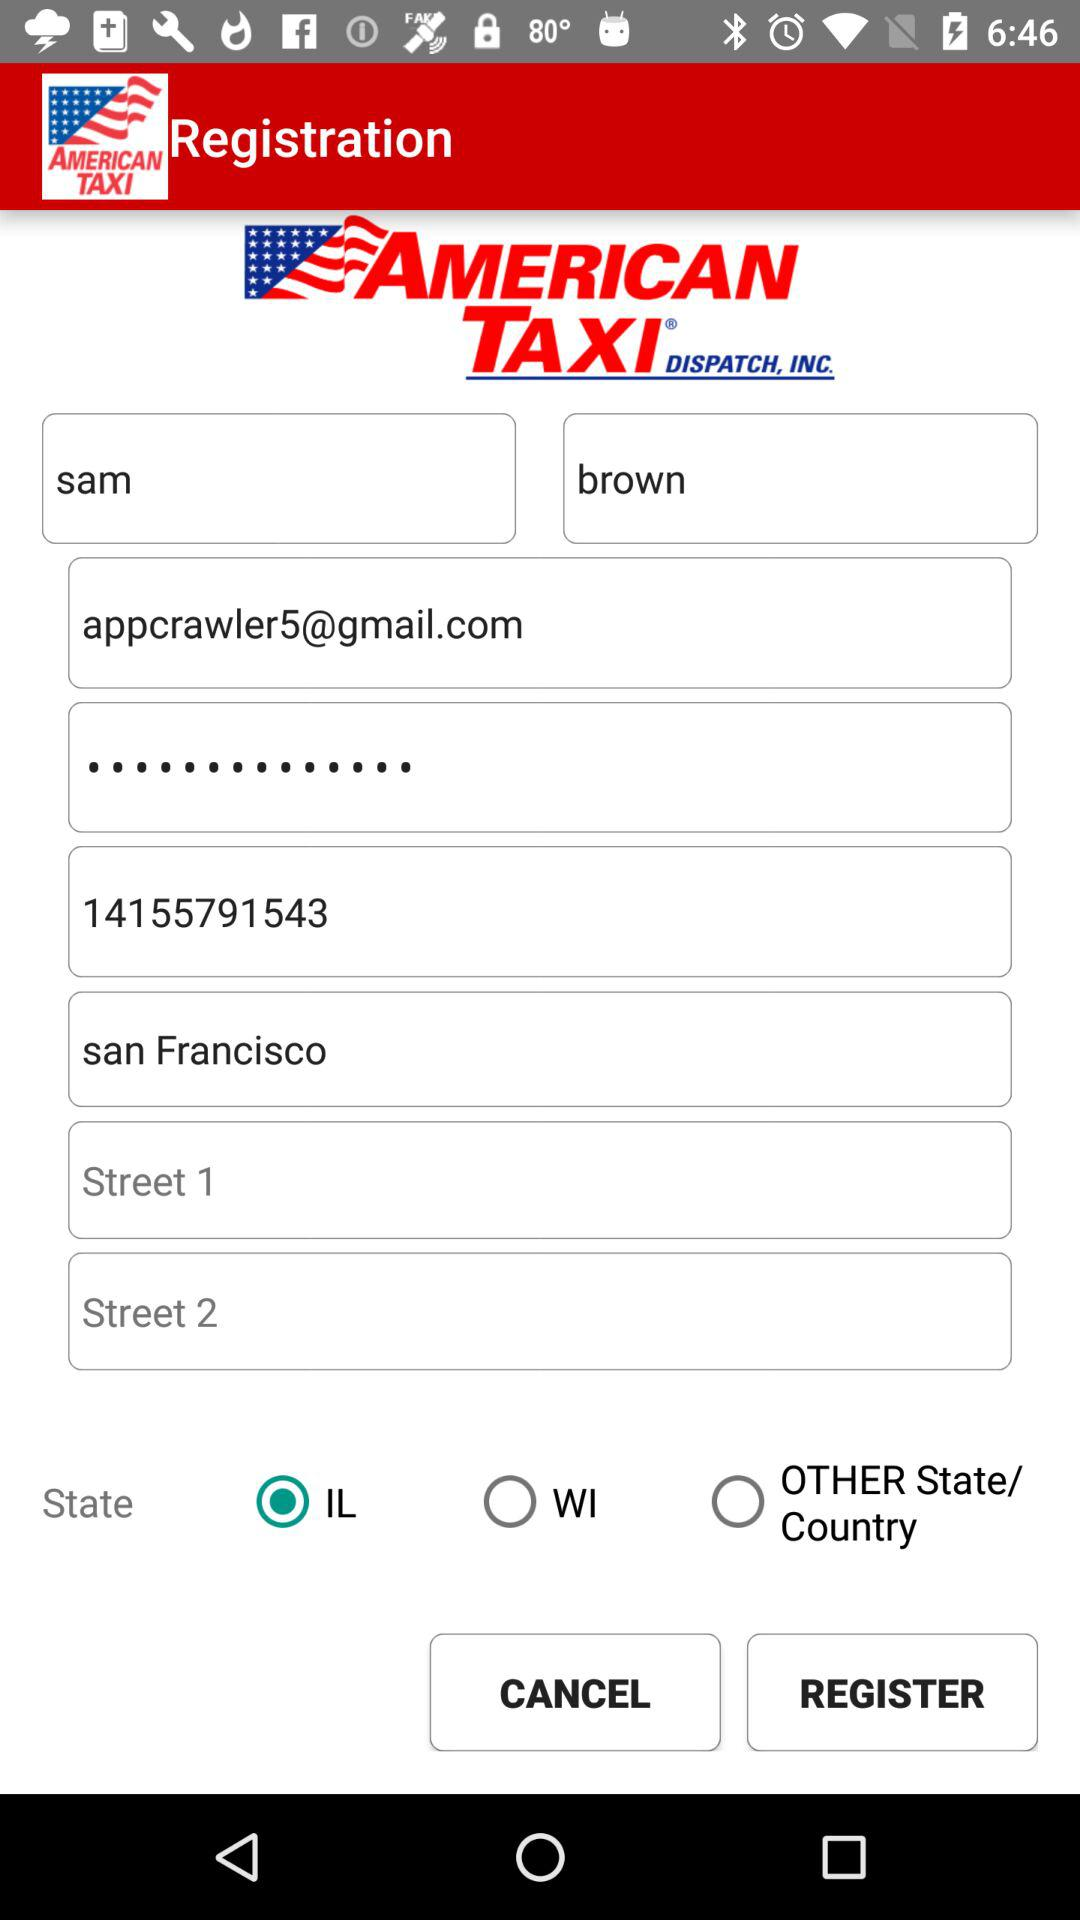What is the location? The location is San Francisco. 